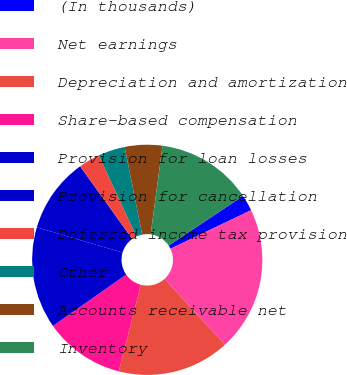Convert chart. <chart><loc_0><loc_0><loc_500><loc_500><pie_chart><fcel>(In thousands)<fcel>Net earnings<fcel>Depreciation and amortization<fcel>Share-based compensation<fcel>Provision for loan losses<fcel>Provision for cancellation<fcel>Deferred income tax provision<fcel>Other<fcel>Accounts receivable net<fcel>Inventory<nl><fcel>2.26%<fcel>20.3%<fcel>15.79%<fcel>11.28%<fcel>14.29%<fcel>10.53%<fcel>3.01%<fcel>3.76%<fcel>5.26%<fcel>13.53%<nl></chart> 